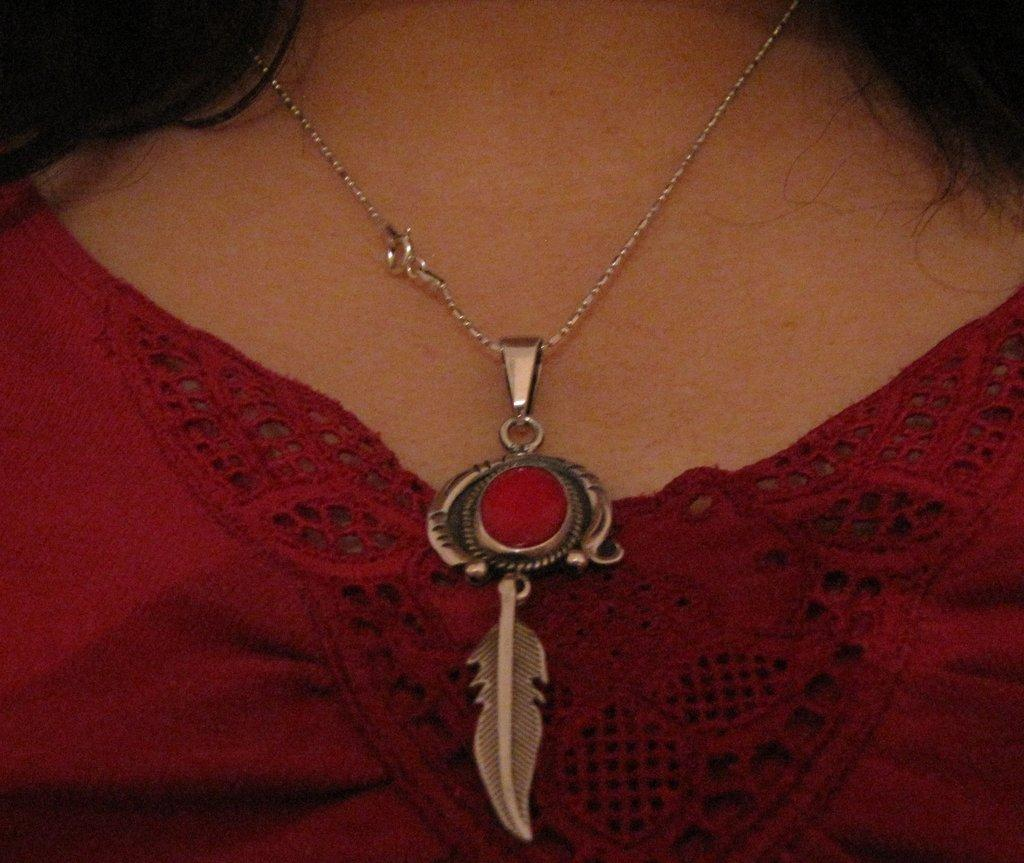What is the main object in the image? There is a pendant in the image. How is the pendant connected to the person in the image? The pendant is attached to a chain, and the chain is around a person's neck. What type of plantation can be seen in the background of the image? There is no plantation visible in the image; it only features a pendant, chain, and a person's neck. 